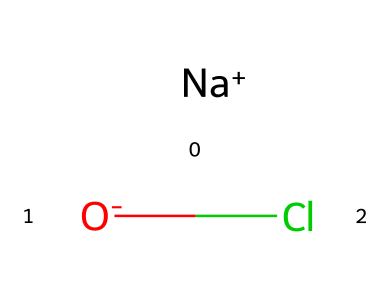What is the name of this chemical? The chemical is composed of sodium (Na), hypochlorite (OCl), hence it is called sodium hypochlorite.
Answer: sodium hypochlorite How many atoms are present in this chemical structure? The structure consists of three different elements: sodium, oxygen, and chlorine. Therefore, there are three atoms in total.
Answer: three What type of bond exists between the sodium and hypochlorite in this compound? Sodium hypochlorite consists of an ionic bond because sodium donates an electron to hypochlorite, forming a positively charged sodium ion and a negatively charged hypochlorite ion.
Answer: ionic bond Is this compound acidic, basic, or neutral in nature? Sodium hypochlorite is generally considered to be a basic compound when dissolved in water due to the formation of hypochlorous acid and its ability to accept protons.
Answer: basic In which household product is sodium hypochlorite commonly found? Sodium hypochlorite is a key ingredient in household bleach, used for cleaning and disinfecting purposes.
Answer: bleach How many covalent bonds are there within the hypochlorite ion (OCl)? In the hypochlorite ion, there is a single covalent bond between the oxygen and chlorine atoms.
Answer: one Can sodium hypochlorite be classified as a stable compound? While sodium hypochlorite can decompose over time, especially in light and heat, it is considered stable enough for household use in dilute solutions.
Answer: stable 